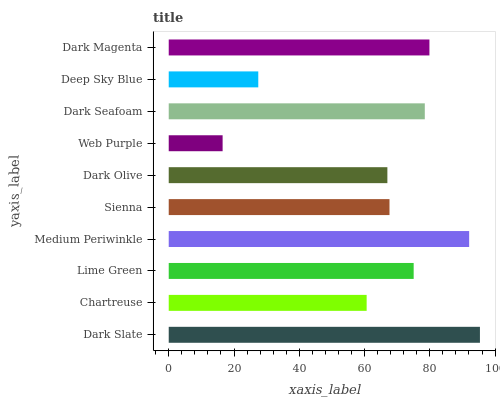Is Web Purple the minimum?
Answer yes or no. Yes. Is Dark Slate the maximum?
Answer yes or no. Yes. Is Chartreuse the minimum?
Answer yes or no. No. Is Chartreuse the maximum?
Answer yes or no. No. Is Dark Slate greater than Chartreuse?
Answer yes or no. Yes. Is Chartreuse less than Dark Slate?
Answer yes or no. Yes. Is Chartreuse greater than Dark Slate?
Answer yes or no. No. Is Dark Slate less than Chartreuse?
Answer yes or no. No. Is Lime Green the high median?
Answer yes or no. Yes. Is Sienna the low median?
Answer yes or no. Yes. Is Chartreuse the high median?
Answer yes or no. No. Is Deep Sky Blue the low median?
Answer yes or no. No. 